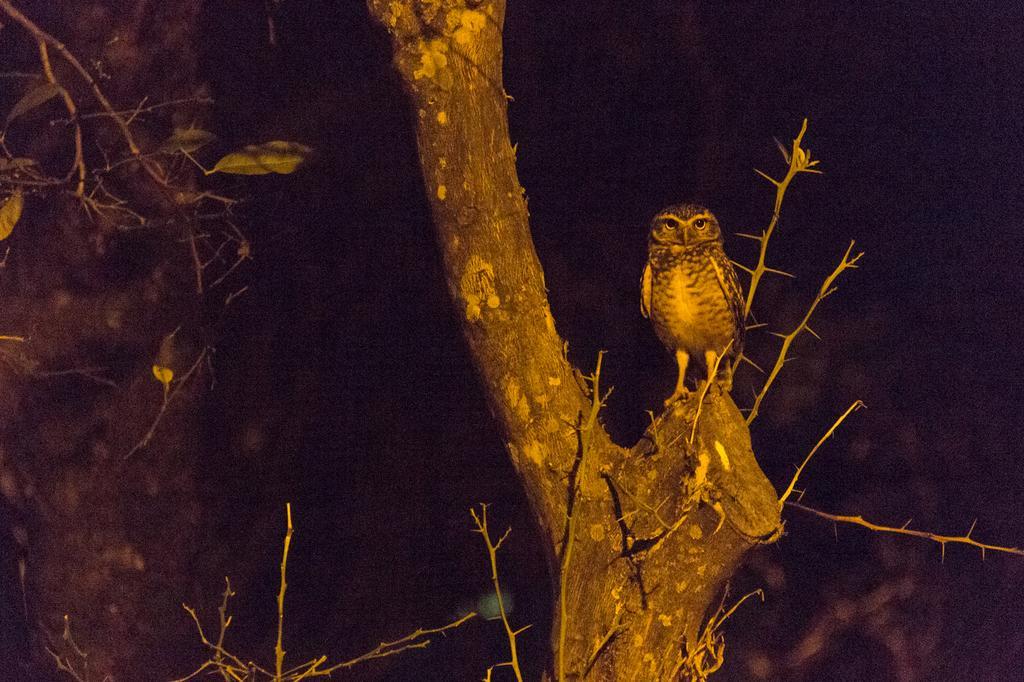How would you summarize this image in a sentence or two? On the right side, there is owl standing on the edge of a branch of tree. On the left side, there are green color leaves of a tree. And the background is dark in color. 